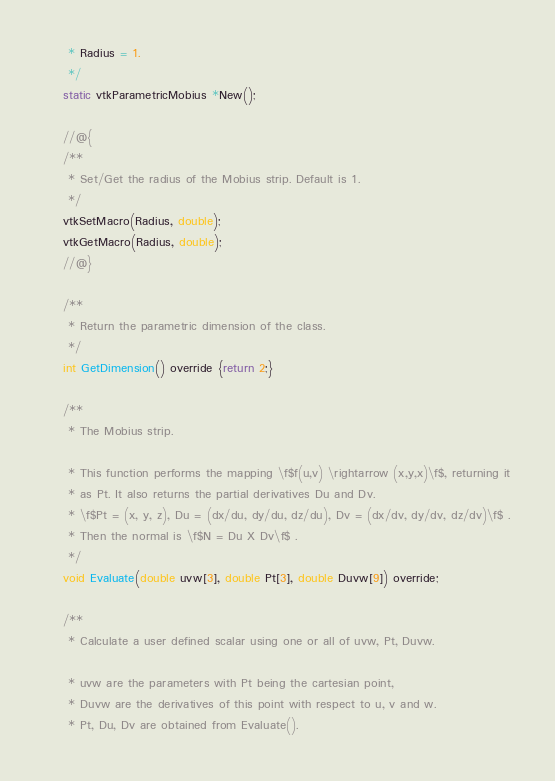Convert code to text. <code><loc_0><loc_0><loc_500><loc_500><_C_>     * Radius = 1.
     */
    static vtkParametricMobius *New();

    //@{
    /**
     * Set/Get the radius of the Mobius strip. Default is 1.
     */
    vtkSetMacro(Radius, double);
    vtkGetMacro(Radius, double);
    //@}

    /**
     * Return the parametric dimension of the class.
     */
    int GetDimension() override {return 2;}

    /**
     * The Mobius strip.

     * This function performs the mapping \f$f(u,v) \rightarrow (x,y,x)\f$, returning it
     * as Pt. It also returns the partial derivatives Du and Dv.
     * \f$Pt = (x, y, z), Du = (dx/du, dy/du, dz/du), Dv = (dx/dv, dy/dv, dz/dv)\f$ .
     * Then the normal is \f$N = Du X Dv\f$ .
     */
    void Evaluate(double uvw[3], double Pt[3], double Duvw[9]) override;

    /**
     * Calculate a user defined scalar using one or all of uvw, Pt, Duvw.

     * uvw are the parameters with Pt being the cartesian point,
     * Duvw are the derivatives of this point with respect to u, v and w.
     * Pt, Du, Dv are obtained from Evaluate().
</code> 